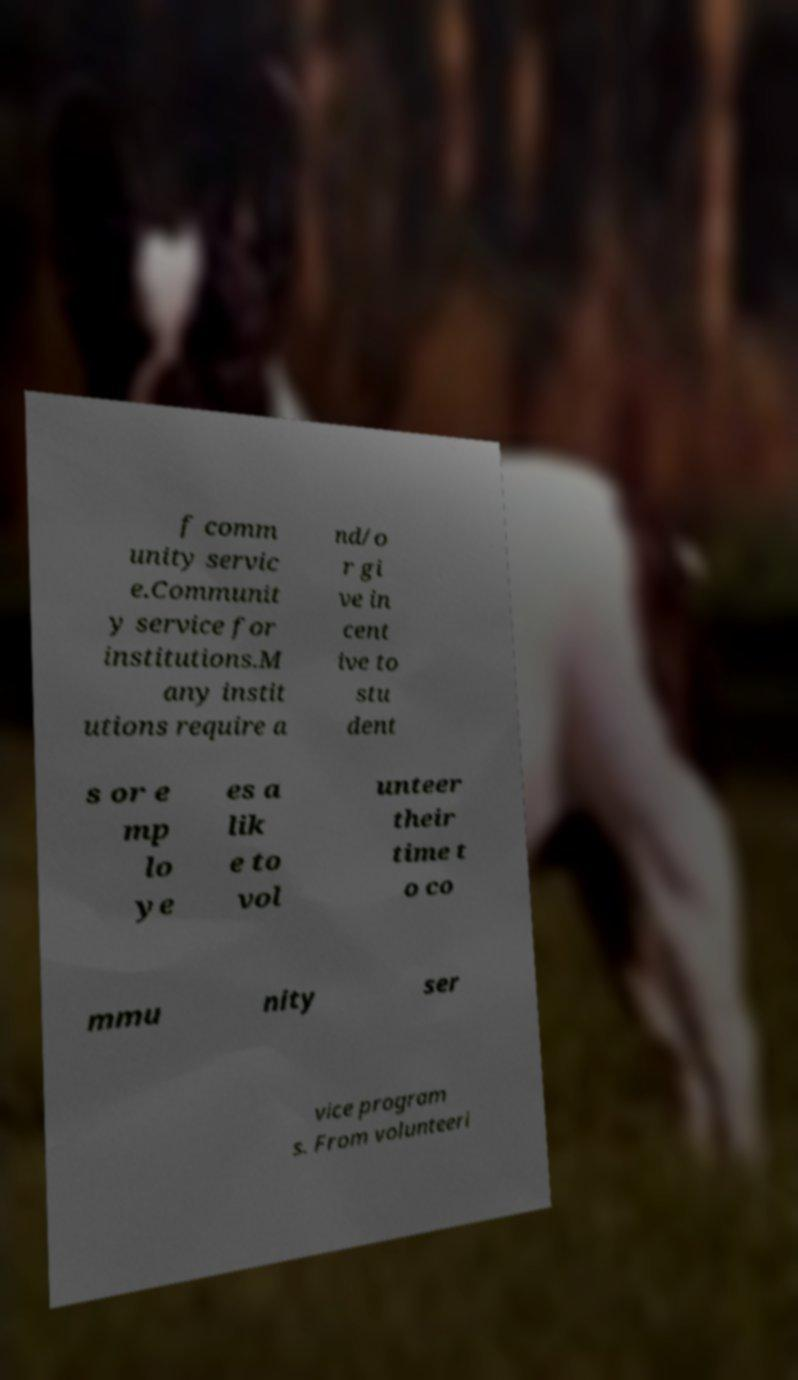I need the written content from this picture converted into text. Can you do that? f comm unity servic e.Communit y service for institutions.M any instit utions require a nd/o r gi ve in cent ive to stu dent s or e mp lo ye es a lik e to vol unteer their time t o co mmu nity ser vice program s. From volunteeri 